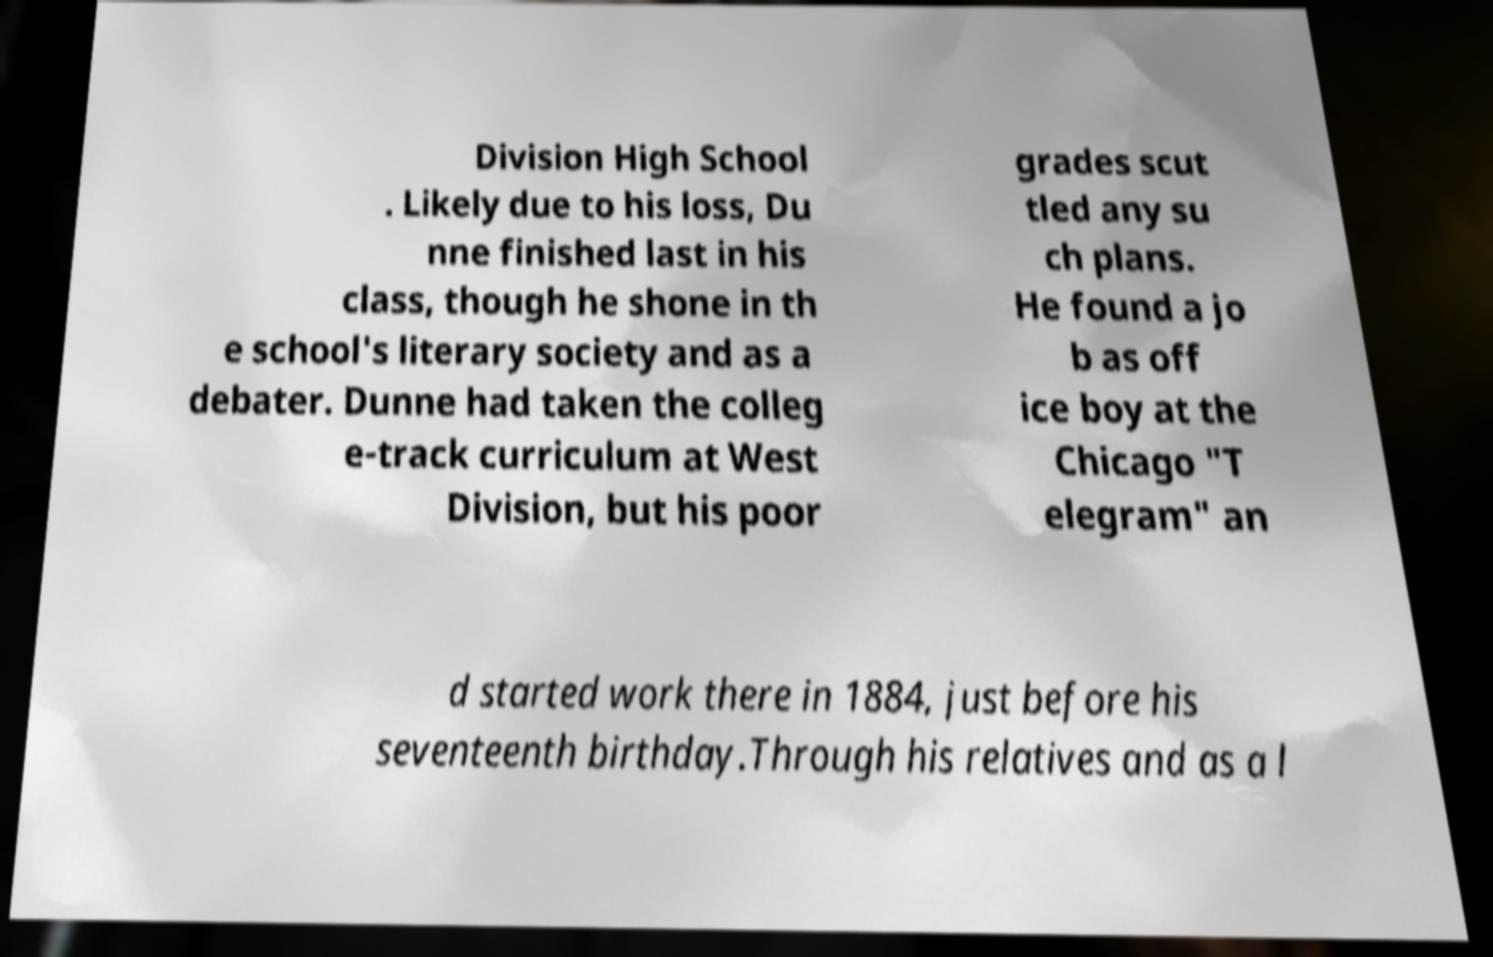For documentation purposes, I need the text within this image transcribed. Could you provide that? Division High School . Likely due to his loss, Du nne finished last in his class, though he shone in th e school's literary society and as a debater. Dunne had taken the colleg e-track curriculum at West Division, but his poor grades scut tled any su ch plans. He found a jo b as off ice boy at the Chicago "T elegram" an d started work there in 1884, just before his seventeenth birthday.Through his relatives and as a l 